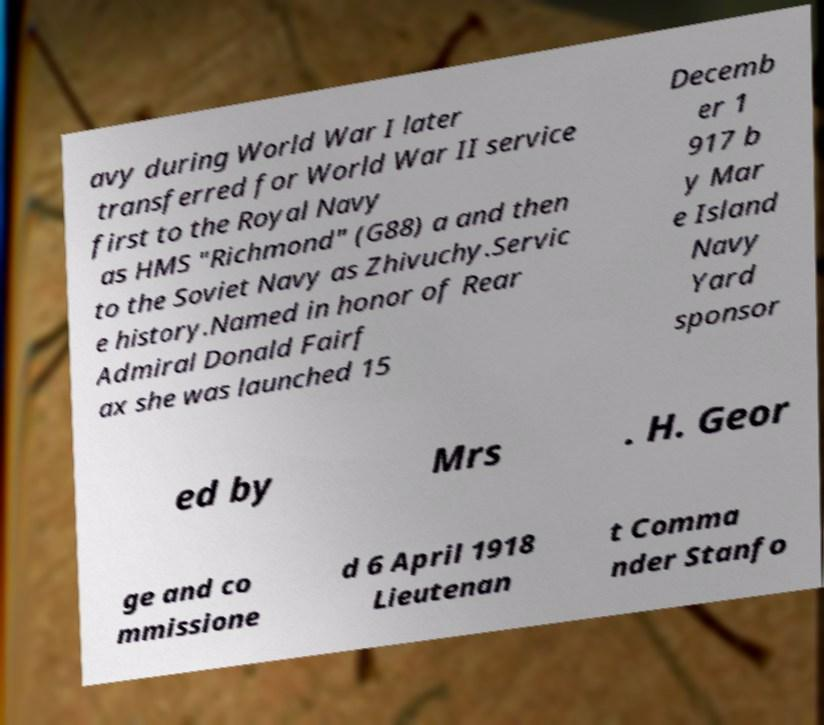Could you assist in decoding the text presented in this image and type it out clearly? avy during World War I later transferred for World War II service first to the Royal Navy as HMS "Richmond" (G88) a and then to the Soviet Navy as Zhivuchy.Servic e history.Named in honor of Rear Admiral Donald Fairf ax she was launched 15 Decemb er 1 917 b y Mar e Island Navy Yard sponsor ed by Mrs . H. Geor ge and co mmissione d 6 April 1918 Lieutenan t Comma nder Stanfo 